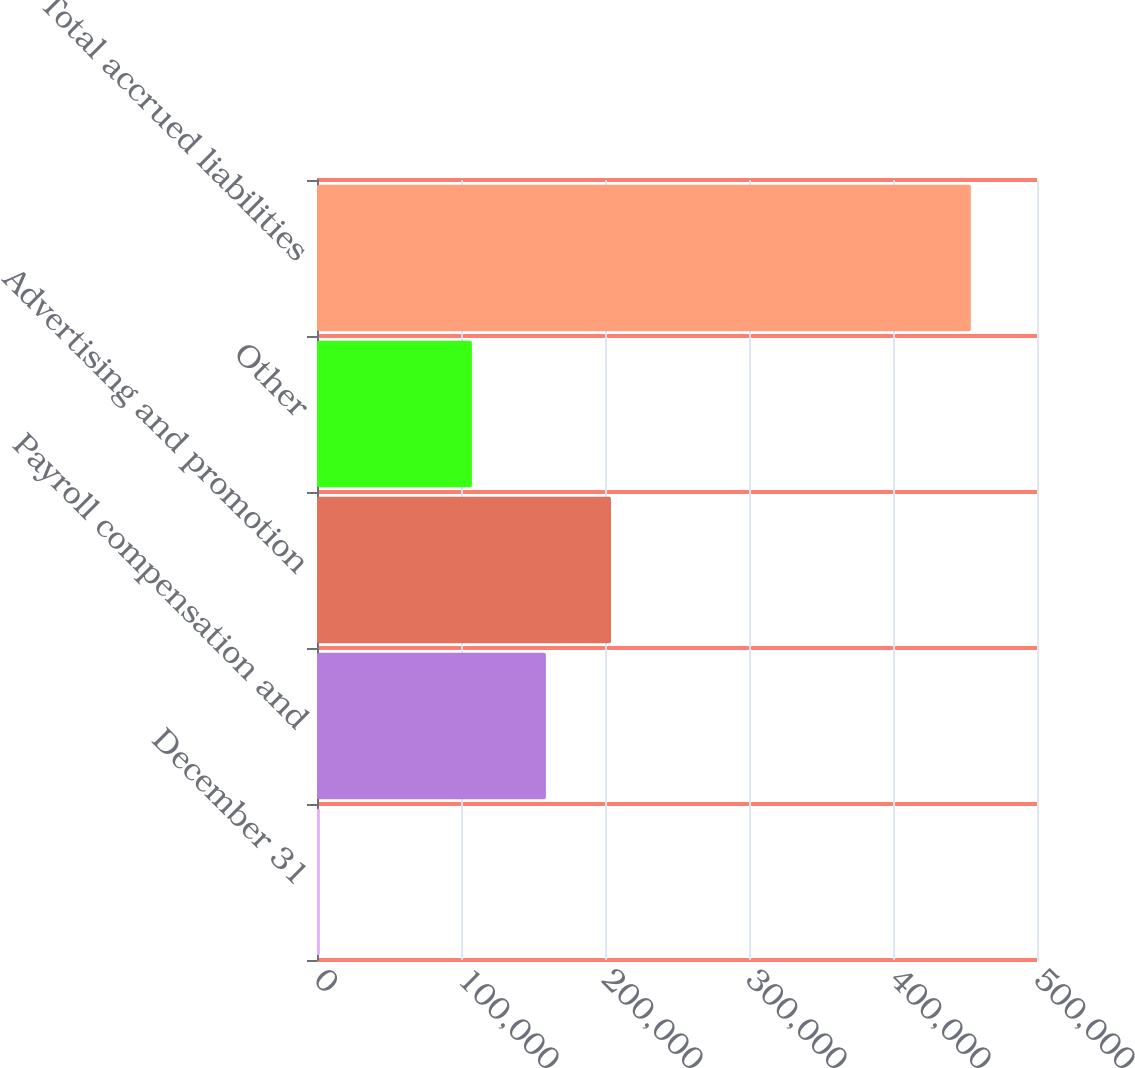Convert chart. <chart><loc_0><loc_0><loc_500><loc_500><bar_chart><fcel>December 31<fcel>Payroll compensation and<fcel>Advertising and promotion<fcel>Other<fcel>Total accrued liabilities<nl><fcel>2006<fcel>158952<fcel>204154<fcel>107577<fcel>454023<nl></chart> 